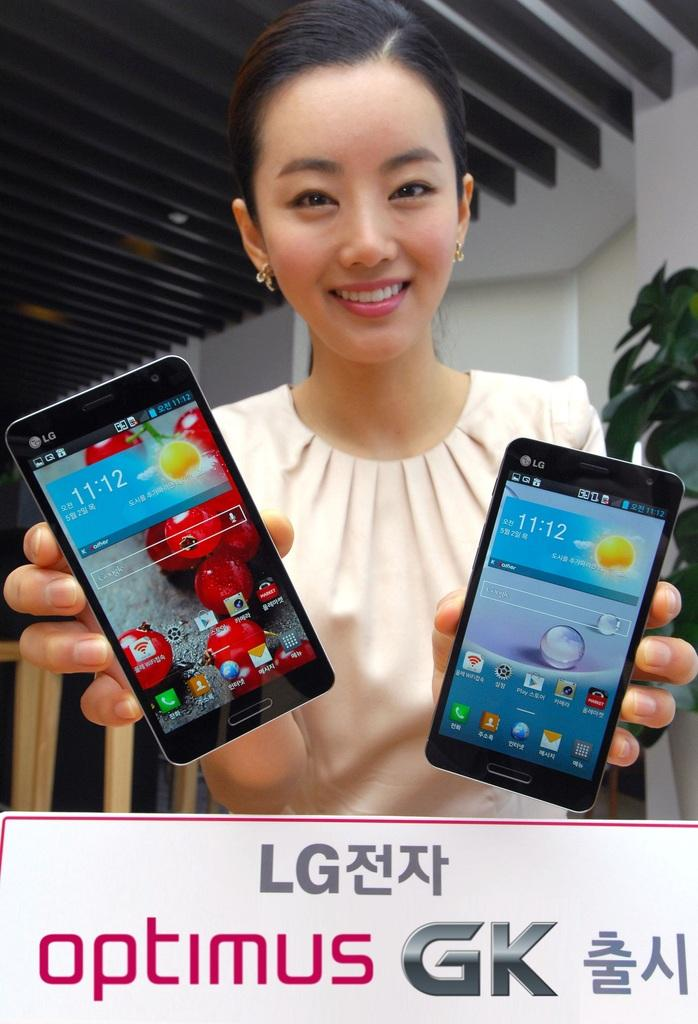<image>
Create a compact narrative representing the image presented. A smiling woman holds an LG cellphone in each hand. 